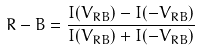Convert formula to latex. <formula><loc_0><loc_0><loc_500><loc_500>R - B = \frac { I ( V _ { R B } ) - I ( - V _ { R B } ) } { I ( V _ { R B } ) + I ( - V _ { R B } ) }</formula> 